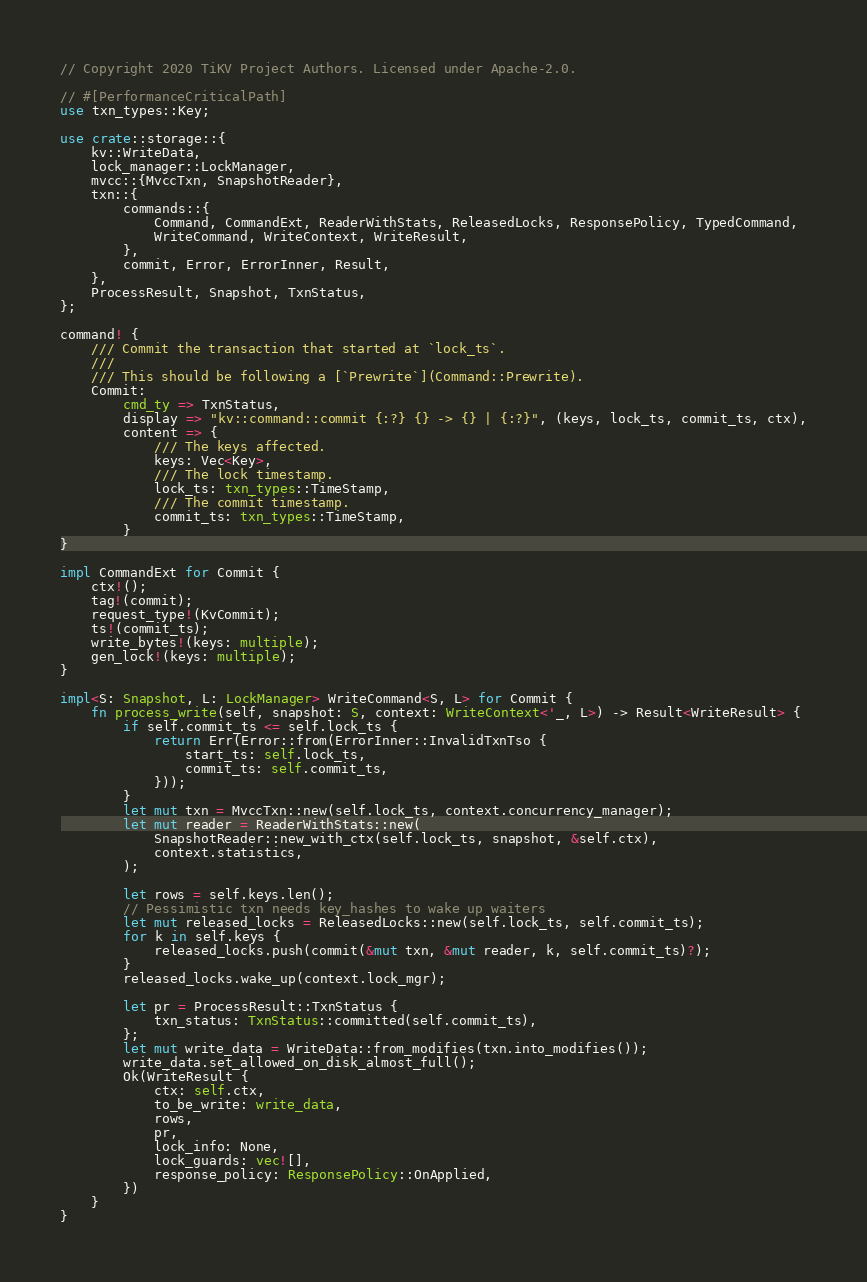Convert code to text. <code><loc_0><loc_0><loc_500><loc_500><_Rust_>// Copyright 2020 TiKV Project Authors. Licensed under Apache-2.0.

// #[PerformanceCriticalPath]
use txn_types::Key;

use crate::storage::{
    kv::WriteData,
    lock_manager::LockManager,
    mvcc::{MvccTxn, SnapshotReader},
    txn::{
        commands::{
            Command, CommandExt, ReaderWithStats, ReleasedLocks, ResponsePolicy, TypedCommand,
            WriteCommand, WriteContext, WriteResult,
        },
        commit, Error, ErrorInner, Result,
    },
    ProcessResult, Snapshot, TxnStatus,
};

command! {
    /// Commit the transaction that started at `lock_ts`.
    ///
    /// This should be following a [`Prewrite`](Command::Prewrite).
    Commit:
        cmd_ty => TxnStatus,
        display => "kv::command::commit {:?} {} -> {} | {:?}", (keys, lock_ts, commit_ts, ctx),
        content => {
            /// The keys affected.
            keys: Vec<Key>,
            /// The lock timestamp.
            lock_ts: txn_types::TimeStamp,
            /// The commit timestamp.
            commit_ts: txn_types::TimeStamp,
        }
}

impl CommandExt for Commit {
    ctx!();
    tag!(commit);
    request_type!(KvCommit);
    ts!(commit_ts);
    write_bytes!(keys: multiple);
    gen_lock!(keys: multiple);
}

impl<S: Snapshot, L: LockManager> WriteCommand<S, L> for Commit {
    fn process_write(self, snapshot: S, context: WriteContext<'_, L>) -> Result<WriteResult> {
        if self.commit_ts <= self.lock_ts {
            return Err(Error::from(ErrorInner::InvalidTxnTso {
                start_ts: self.lock_ts,
                commit_ts: self.commit_ts,
            }));
        }
        let mut txn = MvccTxn::new(self.lock_ts, context.concurrency_manager);
        let mut reader = ReaderWithStats::new(
            SnapshotReader::new_with_ctx(self.lock_ts, snapshot, &self.ctx),
            context.statistics,
        );

        let rows = self.keys.len();
        // Pessimistic txn needs key_hashes to wake up waiters
        let mut released_locks = ReleasedLocks::new(self.lock_ts, self.commit_ts);
        for k in self.keys {
            released_locks.push(commit(&mut txn, &mut reader, k, self.commit_ts)?);
        }
        released_locks.wake_up(context.lock_mgr);

        let pr = ProcessResult::TxnStatus {
            txn_status: TxnStatus::committed(self.commit_ts),
        };
        let mut write_data = WriteData::from_modifies(txn.into_modifies());
        write_data.set_allowed_on_disk_almost_full();
        Ok(WriteResult {
            ctx: self.ctx,
            to_be_write: write_data,
            rows,
            pr,
            lock_info: None,
            lock_guards: vec![],
            response_policy: ResponsePolicy::OnApplied,
        })
    }
}
</code> 